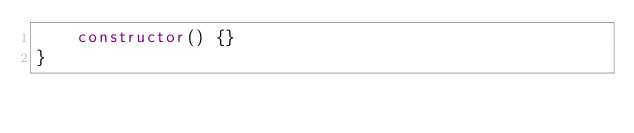<code> <loc_0><loc_0><loc_500><loc_500><_TypeScript_>    constructor() {}
}
</code> 